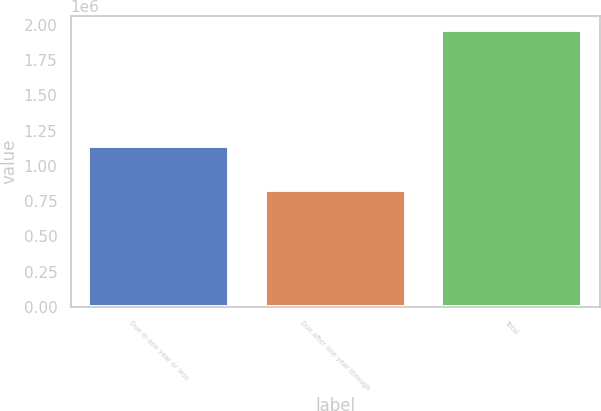Convert chart. <chart><loc_0><loc_0><loc_500><loc_500><bar_chart><fcel>Due in one year or less<fcel>Due after one year through<fcel>Total<nl><fcel>1.13782e+06<fcel>828848<fcel>1.96667e+06<nl></chart> 